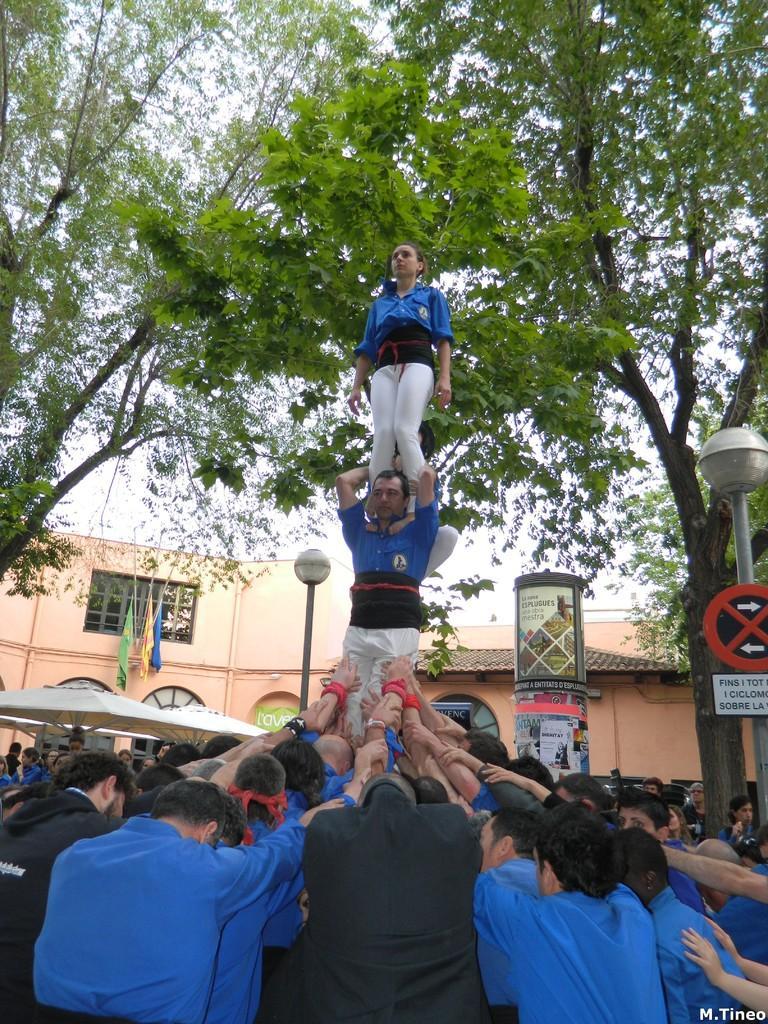Could you give a brief overview of what you see in this image? In the center of the image we can see a few people are standing and they are holding one person. And that person holding one more person and they are in different costumes. At the bottom right side of the image, we can see some text. In the background, we can see the sky, clouds, trees, one building, banners, one sign board, flags and a few other objects. On the banners, we can see some text. 